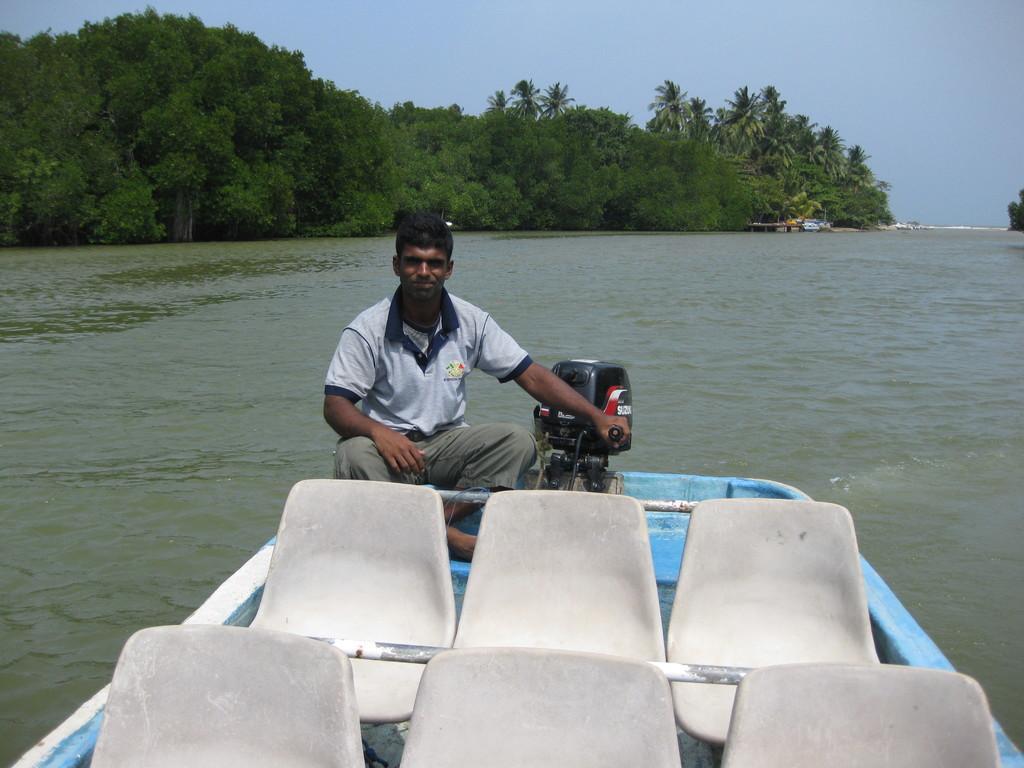Could you give a brief overview of what you see in this image? In this image, we can see a person is watching and smiling. He is sitting on a boat and holding an object. Beside him, there is a motor. Here we can see seats and rods. Background we can see the water, trees and sky. 